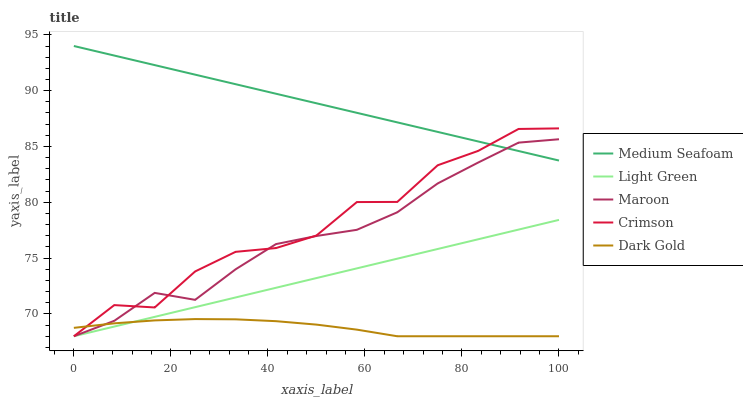Does Maroon have the minimum area under the curve?
Answer yes or no. No. Does Maroon have the maximum area under the curve?
Answer yes or no. No. Is Maroon the smoothest?
Answer yes or no. No. Is Maroon the roughest?
Answer yes or no. No. Does Medium Seafoam have the lowest value?
Answer yes or no. No. Does Maroon have the highest value?
Answer yes or no. No. Is Light Green less than Medium Seafoam?
Answer yes or no. Yes. Is Medium Seafoam greater than Light Green?
Answer yes or no. Yes. Does Light Green intersect Medium Seafoam?
Answer yes or no. No. 